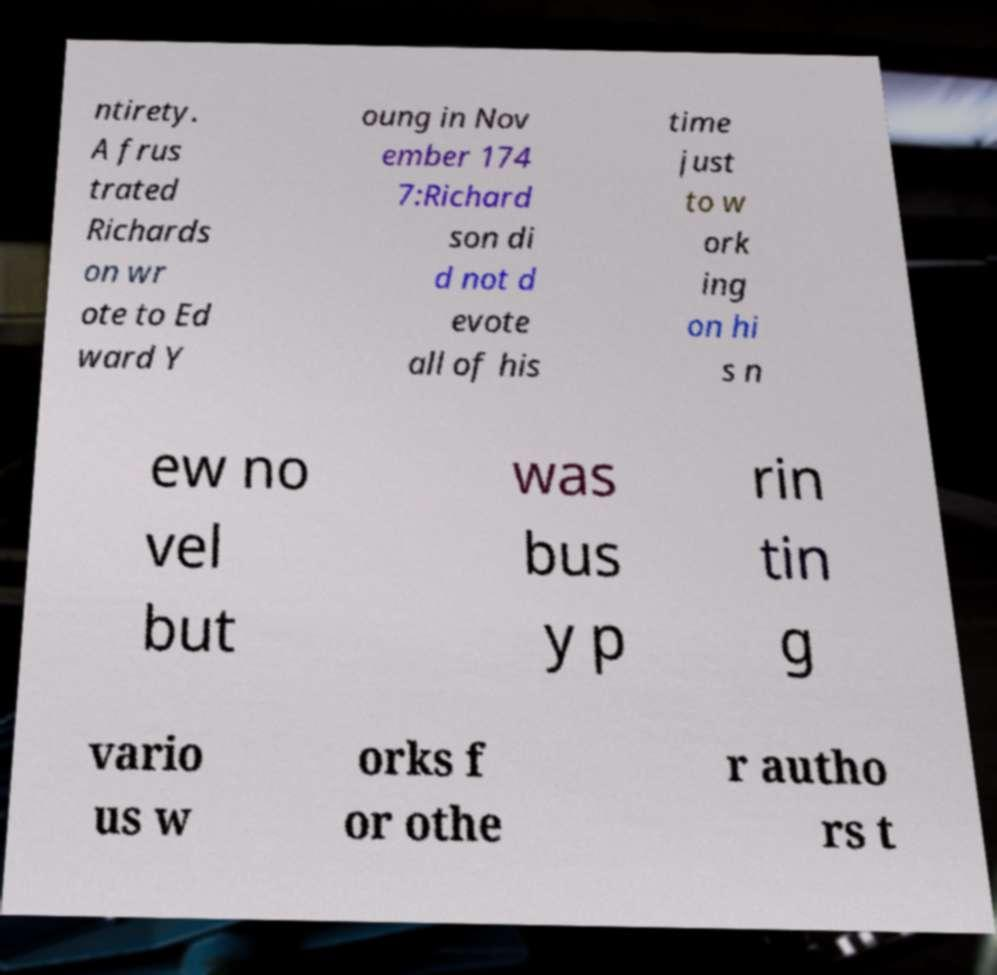Could you assist in decoding the text presented in this image and type it out clearly? ntirety. A frus trated Richards on wr ote to Ed ward Y oung in Nov ember 174 7:Richard son di d not d evote all of his time just to w ork ing on hi s n ew no vel but was bus y p rin tin g vario us w orks f or othe r autho rs t 